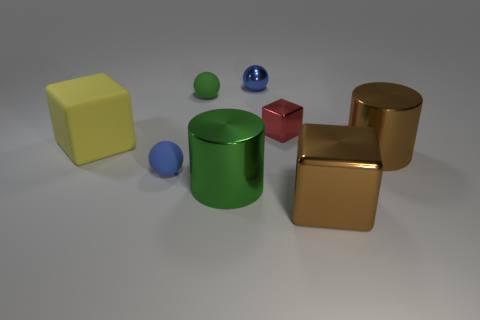Add 1 large yellow shiny cylinders. How many objects exist? 9 Subtract all balls. How many objects are left? 5 Add 1 green matte balls. How many green matte balls exist? 2 Subtract 0 blue cylinders. How many objects are left? 8 Subtract all yellow matte cylinders. Subtract all brown blocks. How many objects are left? 7 Add 6 rubber spheres. How many rubber spheres are left? 8 